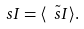Convert formula to latex. <formula><loc_0><loc_0><loc_500><loc_500>\ s I = \langle \tilde { \ s I } \rangle .</formula> 